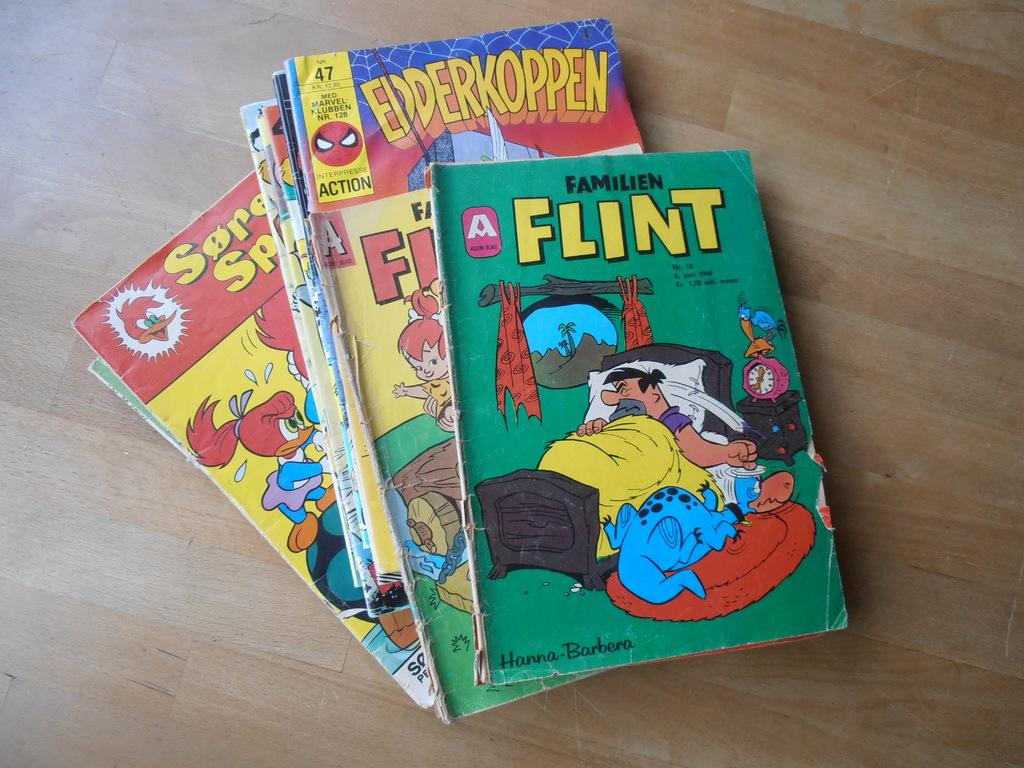Provide a one-sentence caption for the provided image. A stack of comic books written by Hanna-Barbera. 